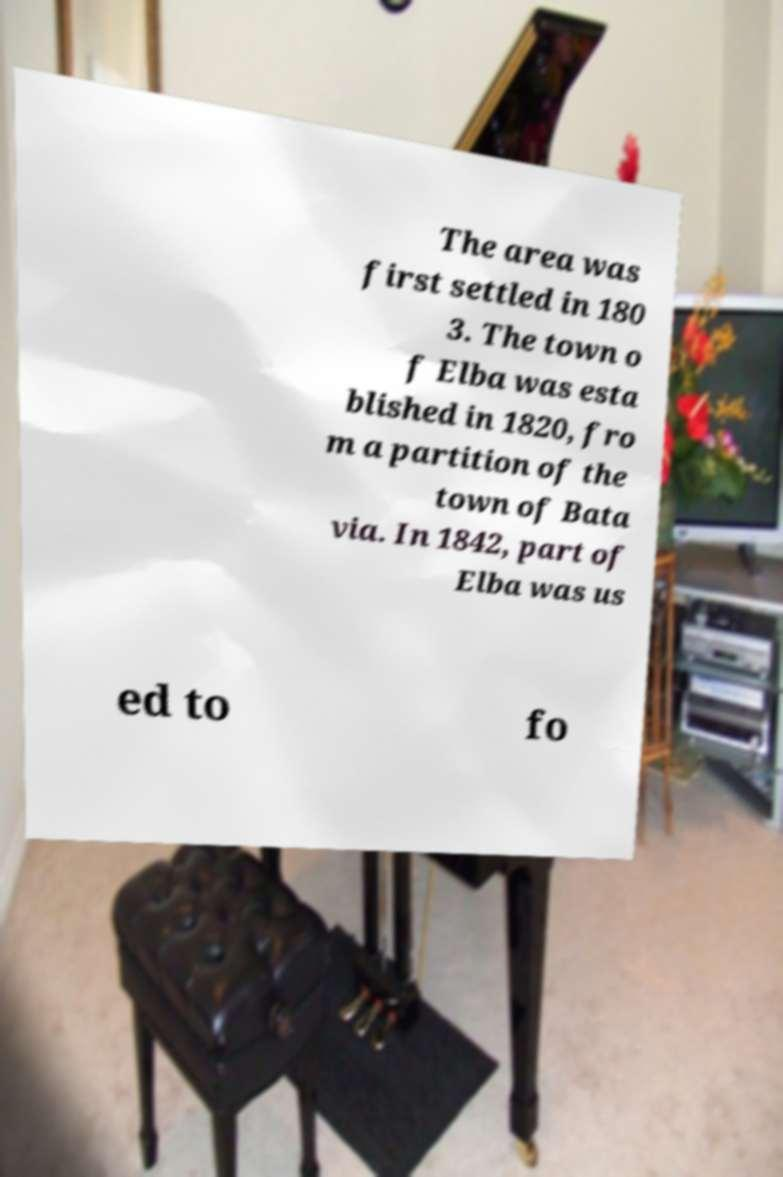Please identify and transcribe the text found in this image. The area was first settled in 180 3. The town o f Elba was esta blished in 1820, fro m a partition of the town of Bata via. In 1842, part of Elba was us ed to fo 